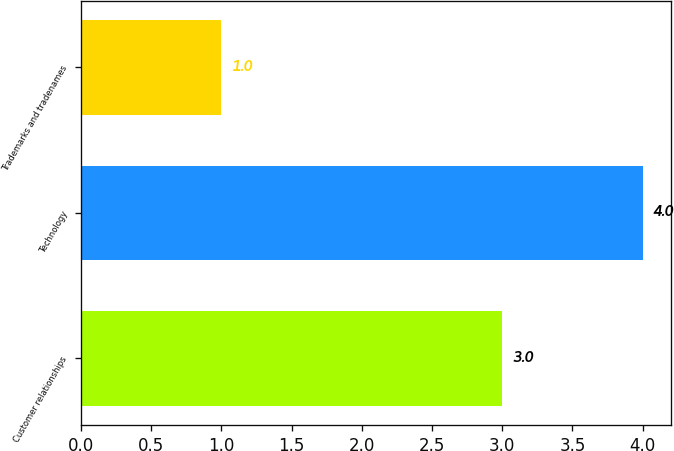Convert chart. <chart><loc_0><loc_0><loc_500><loc_500><bar_chart><fcel>Customer relationships<fcel>Technology<fcel>Trademarks and tradenames<nl><fcel>3<fcel>4<fcel>1<nl></chart> 